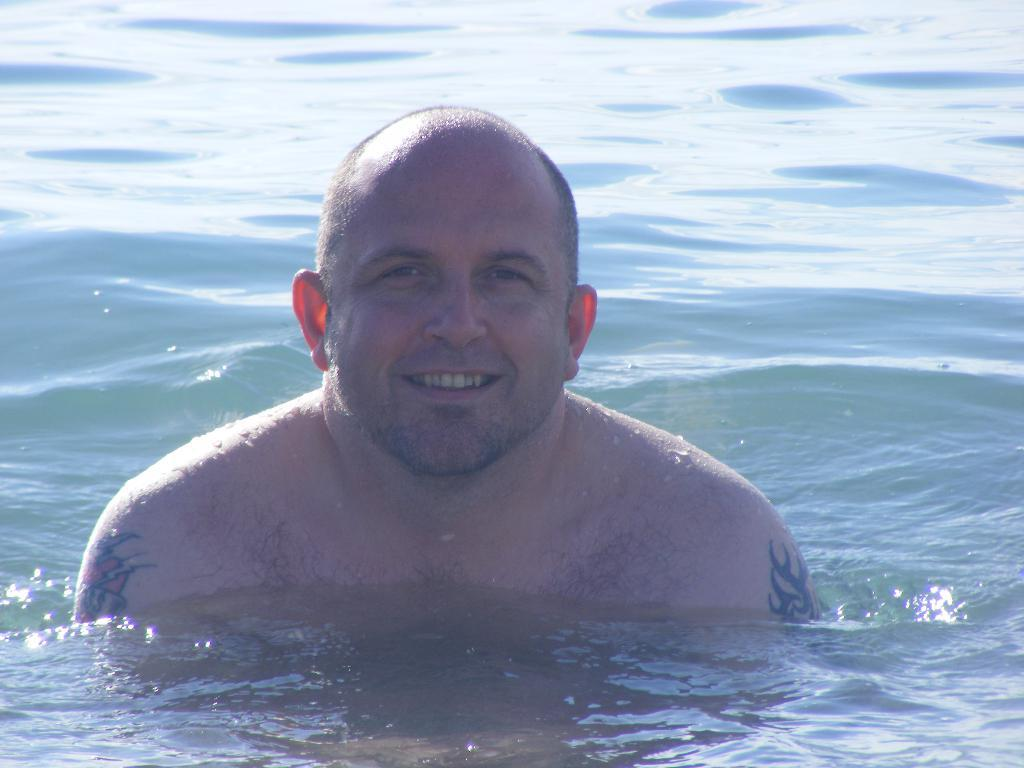What is present in the image that is not a person or object? There is water in the image. Can you describe the person in the image? There is a man in the image, and he is smiling. Are there any distinguishing features about the man? Yes, the man has tattoos on his body. What type of sack is the man carrying in the image? There is no sack present in the image. What religion does the man in the image practice? There is no information about the man's religion in the image. 